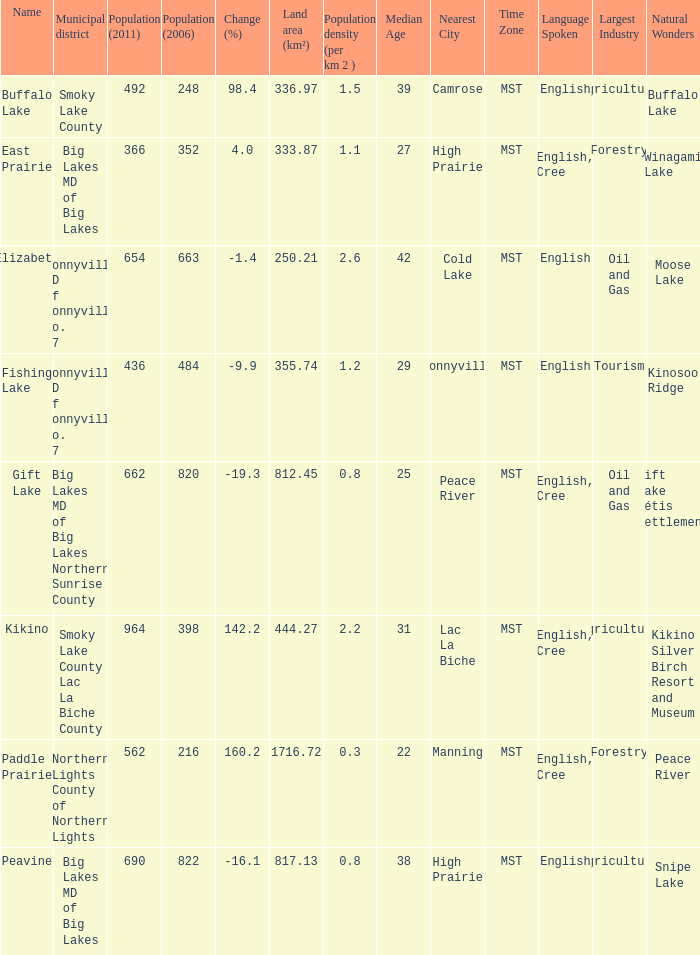What is the population per km in Smoky Lake County? 1.5. 